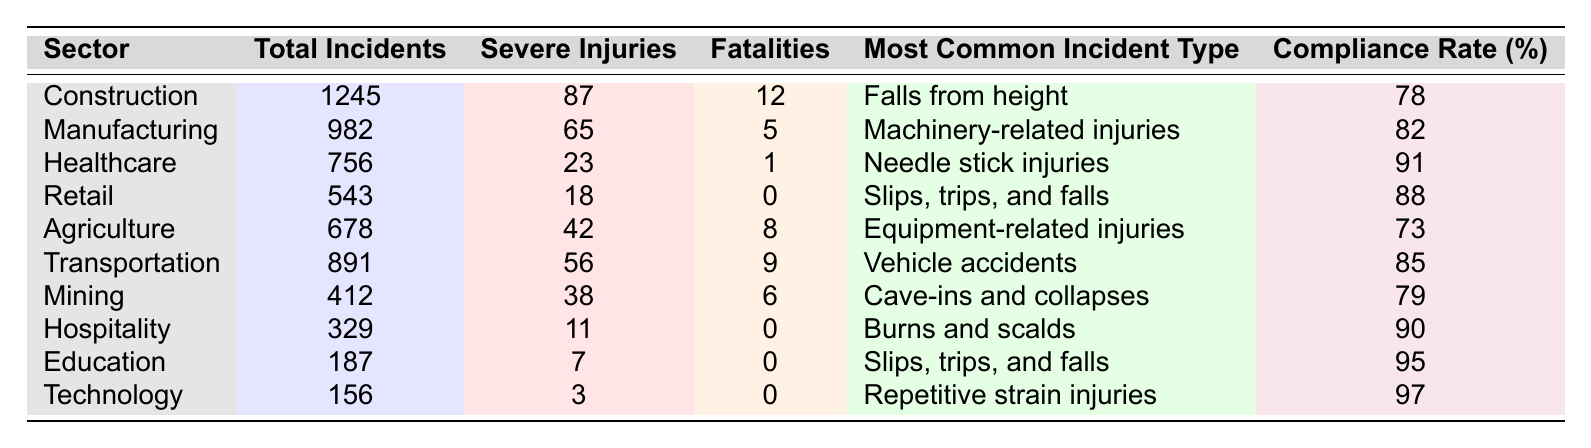What is the total number of incidents reported in the Construction sector? The table shows that the Construction sector had 1245 total incidents reported.
Answer: 1245 Which sector has the highest number of fatalities? By comparing the fatalities column, the Construction sector has 12 fatalities, which is higher than any other sector.
Answer: Construction What is the compliance rate for the Healthcare sector? The compliance rate for the Healthcare sector is listed as 91%.
Answer: 91% How many sectors report zero fatalities? By checking the table, the Retail, Hospitality, Education, and Technology sectors all report zero fatalities, making it four sectors in total.
Answer: 4 What is the most common incident type in the Agriculture sector? The table specifies that the most common incident type in the Agriculture sector is "Equipment-related injuries."
Answer: Equipment-related injuries Which sector has the least number of total incidents? Looking at the Total Incidents column, the Technology sector has the least with a total of 156 incidents.
Answer: Technology What is the average number of severe injuries across all sectors? To find the average, sum all severe injuries (87 + 65 + 23 + 18 + 42 + 56 + 38 + 11 + 7 + 3 = 350) and divide by the number of sectors (10), resulting in an average of 35.
Answer: 35 Is the compliance rate for the Mining sector above 80%? The compliance rate for the Mining sector is 79%, which is below 80%.
Answer: No Which sector has the highest compliance rate? The Technology sector has the highest compliance rate at 97%, as noted in the Compliance Rate column.
Answer: Technology How many total severe injuries were reported in the Manufacturing and Transportation sectors combined? Add the severe injuries from both sectors (65 from Manufacturing + 56 from Transportation = 121).
Answer: 121 